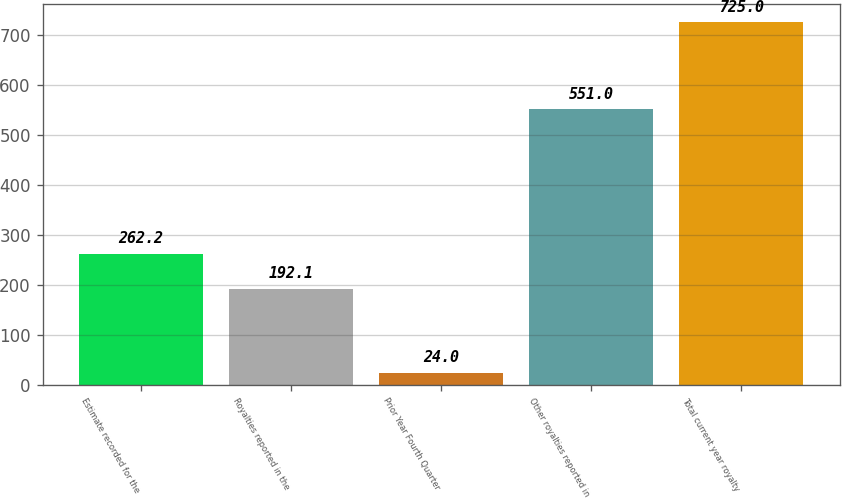<chart> <loc_0><loc_0><loc_500><loc_500><bar_chart><fcel>Estimate recorded for the<fcel>Royalties reported in the<fcel>Prior Year Fourth Quarter<fcel>Other royalties reported in<fcel>Total current year royalty<nl><fcel>262.2<fcel>192.1<fcel>24<fcel>551<fcel>725<nl></chart> 